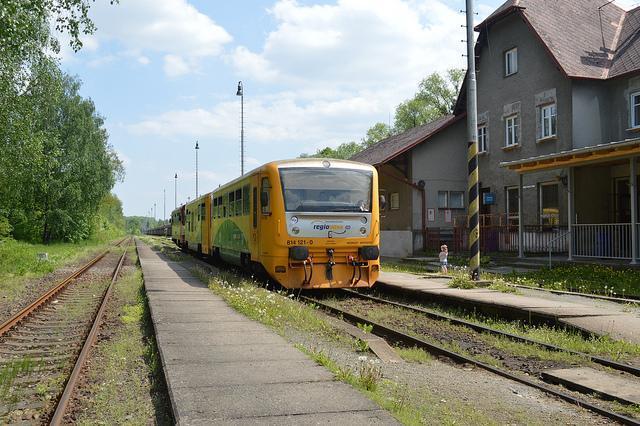How many tracks are in the shot?
Give a very brief answer. 2. How many birds is the woman holding?
Give a very brief answer. 0. 